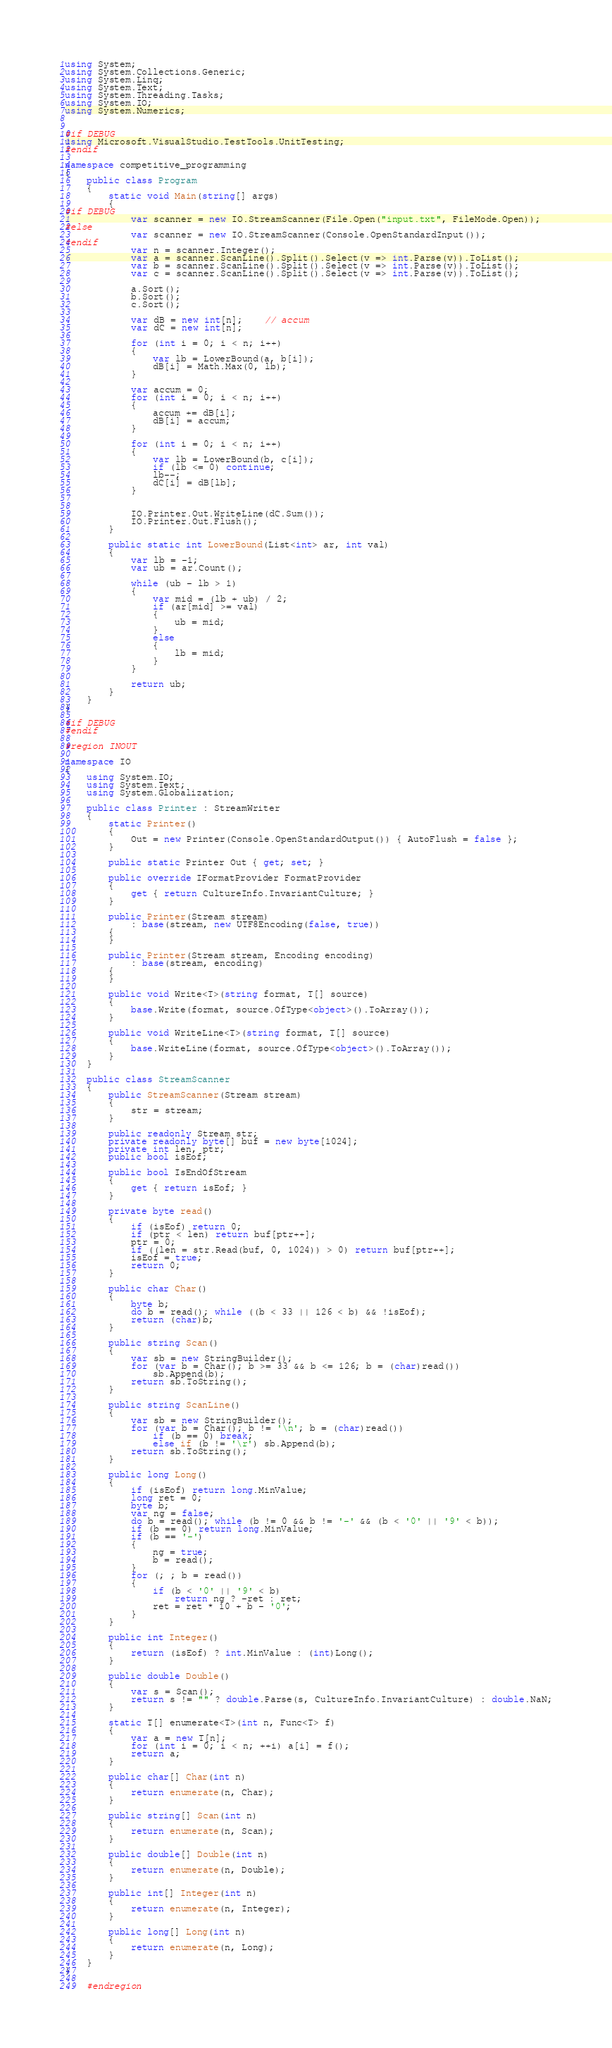Convert code to text. <code><loc_0><loc_0><loc_500><loc_500><_C#_>using System;
using System.Collections.Generic;
using System.Linq;
using System.Text;
using System.Threading.Tasks;
using System.IO;
using System.Numerics;


#if DEBUG
using Microsoft.VisualStudio.TestTools.UnitTesting;
#endif

namespace competitive_programming
{
    public class Program
    {
        static void Main(string[] args)
        {
#if DEBUG
            var scanner = new IO.StreamScanner(File.Open("input.txt", FileMode.Open));
#else
            var scanner = new IO.StreamScanner(Console.OpenStandardInput());
#endif
            var n = scanner.Integer();
            var a = scanner.ScanLine().Split().Select(v => int.Parse(v)).ToList();
            var b = scanner.ScanLine().Split().Select(v => int.Parse(v)).ToList();
            var c = scanner.ScanLine().Split().Select(v => int.Parse(v)).ToList();

            a.Sort();
            b.Sort();
            c.Sort();

            var dB = new int[n];    // accum
            var dC = new int[n];

            for (int i = 0; i < n; i++)
            {
                var lb = LowerBound(a, b[i]);
                dB[i] = Math.Max(0, lb);
            }

            var accum = 0;
            for (int i = 0; i < n; i++)
            {
                accum += dB[i];
                dB[i] = accum;
            }

            for (int i = 0; i < n; i++)
            {
                var lb = LowerBound(b, c[i]);
                if (lb <= 0) continue;
                lb--;
                dC[i] = dB[lb];
            }


            IO.Printer.Out.WriteLine(dC.Sum());
            IO.Printer.Out.Flush();
        }

        public static int LowerBound(List<int> ar, int val)
        {
            var lb = -1;
            var ub = ar.Count();

            while (ub - lb > 1)
            {
                var mid = (lb + ub) / 2;
                if (ar[mid] >= val)
                {
                    ub = mid;
                }
                else
                {
                    lb = mid;
                }
            }

            return ub;
        }
    }
}

#if DEBUG
#endif

#region INOUT

namespace IO
{
    using System.IO;
    using System.Text;
    using System.Globalization;

    public class Printer : StreamWriter
    {
        static Printer()
        {
            Out = new Printer(Console.OpenStandardOutput()) { AutoFlush = false };
        }

        public static Printer Out { get; set; }

        public override IFormatProvider FormatProvider
        {
            get { return CultureInfo.InvariantCulture; }
        }

        public Printer(Stream stream)
            : base(stream, new UTF8Encoding(false, true))
        {
        }

        public Printer(Stream stream, Encoding encoding)
            : base(stream, encoding)
        {
        }

        public void Write<T>(string format, T[] source)
        {
            base.Write(format, source.OfType<object>().ToArray());
        }

        public void WriteLine<T>(string format, T[] source)
        {
            base.WriteLine(format, source.OfType<object>().ToArray());
        }
    }

    public class StreamScanner
    {
        public StreamScanner(Stream stream)
        {
            str = stream;
        }

        public readonly Stream str;
        private readonly byte[] buf = new byte[1024];
        private int len, ptr;
        public bool isEof;

        public bool IsEndOfStream
        {
            get { return isEof; }
        }

        private byte read()
        {
            if (isEof) return 0;
            if (ptr < len) return buf[ptr++];
            ptr = 0;
            if ((len = str.Read(buf, 0, 1024)) > 0) return buf[ptr++];
            isEof = true;
            return 0;
        }

        public char Char()
        {
            byte b;
            do b = read(); while ((b < 33 || 126 < b) && !isEof);
            return (char)b;
        }

        public string Scan()
        {
            var sb = new StringBuilder();
            for (var b = Char(); b >= 33 && b <= 126; b = (char)read())
                sb.Append(b);
            return sb.ToString();
        }

        public string ScanLine()
        {
            var sb = new StringBuilder();
            for (var b = Char(); b != '\n'; b = (char)read())
                if (b == 0) break;
                else if (b != '\r') sb.Append(b);
            return sb.ToString();
        }

        public long Long()
        {
            if (isEof) return long.MinValue;
            long ret = 0;
            byte b;
            var ng = false;
            do b = read(); while (b != 0 && b != '-' && (b < '0' || '9' < b));
            if (b == 0) return long.MinValue;
            if (b == '-')
            {
                ng = true;
                b = read();
            }
            for (; ; b = read())
            {
                if (b < '0' || '9' < b)
                    return ng ? -ret : ret;
                ret = ret * 10 + b - '0';
            }
        }

        public int Integer()
        {
            return (isEof) ? int.MinValue : (int)Long();
        }

        public double Double()
        {
            var s = Scan();
            return s != "" ? double.Parse(s, CultureInfo.InvariantCulture) : double.NaN;
        }

        static T[] enumerate<T>(int n, Func<T> f)
        {
            var a = new T[n];
            for (int i = 0; i < n; ++i) a[i] = f();
            return a;
        }

        public char[] Char(int n)
        {
            return enumerate(n, Char);
        }

        public string[] Scan(int n)
        {
            return enumerate(n, Scan);
        }

        public double[] Double(int n)
        {
            return enumerate(n, Double);
        }

        public int[] Integer(int n)
        {
            return enumerate(n, Integer);
        }

        public long[] Long(int n)
        {
            return enumerate(n, Long);
        }
    }
}

    #endregion</code> 